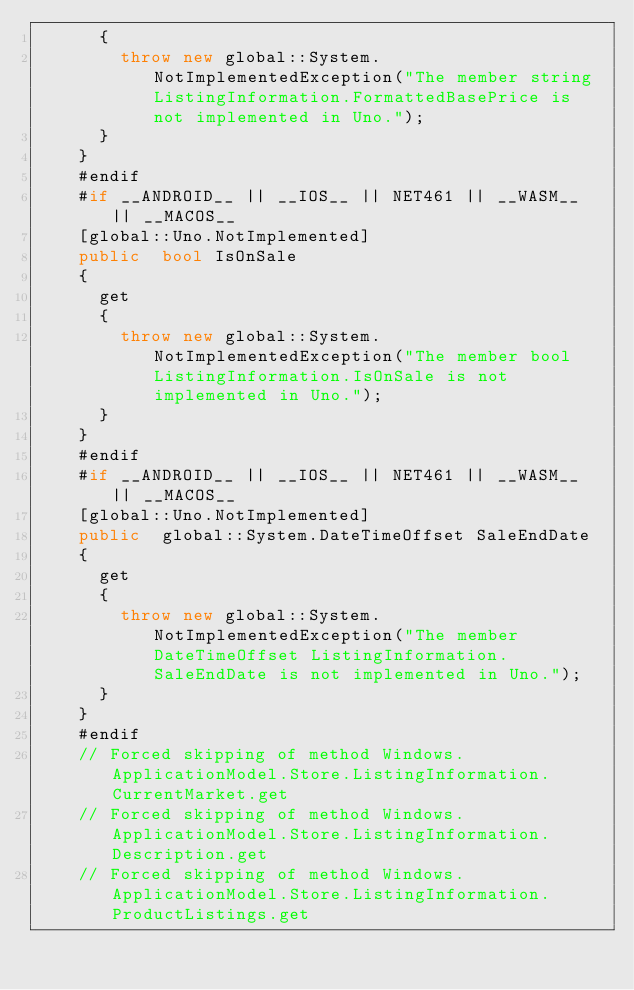<code> <loc_0><loc_0><loc_500><loc_500><_C#_>			{
				throw new global::System.NotImplementedException("The member string ListingInformation.FormattedBasePrice is not implemented in Uno.");
			}
		}
		#endif
		#if __ANDROID__ || __IOS__ || NET461 || __WASM__ || __MACOS__
		[global::Uno.NotImplemented]
		public  bool IsOnSale
		{
			get
			{
				throw new global::System.NotImplementedException("The member bool ListingInformation.IsOnSale is not implemented in Uno.");
			}
		}
		#endif
		#if __ANDROID__ || __IOS__ || NET461 || __WASM__ || __MACOS__
		[global::Uno.NotImplemented]
		public  global::System.DateTimeOffset SaleEndDate
		{
			get
			{
				throw new global::System.NotImplementedException("The member DateTimeOffset ListingInformation.SaleEndDate is not implemented in Uno.");
			}
		}
		#endif
		// Forced skipping of method Windows.ApplicationModel.Store.ListingInformation.CurrentMarket.get
		// Forced skipping of method Windows.ApplicationModel.Store.ListingInformation.Description.get
		// Forced skipping of method Windows.ApplicationModel.Store.ListingInformation.ProductListings.get</code> 